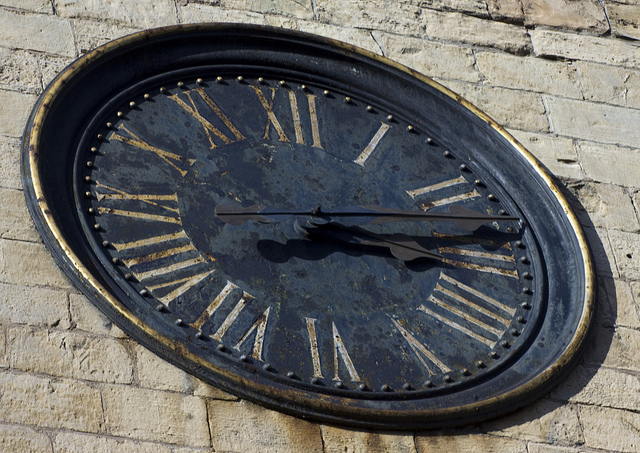How many clocks are there? 1 